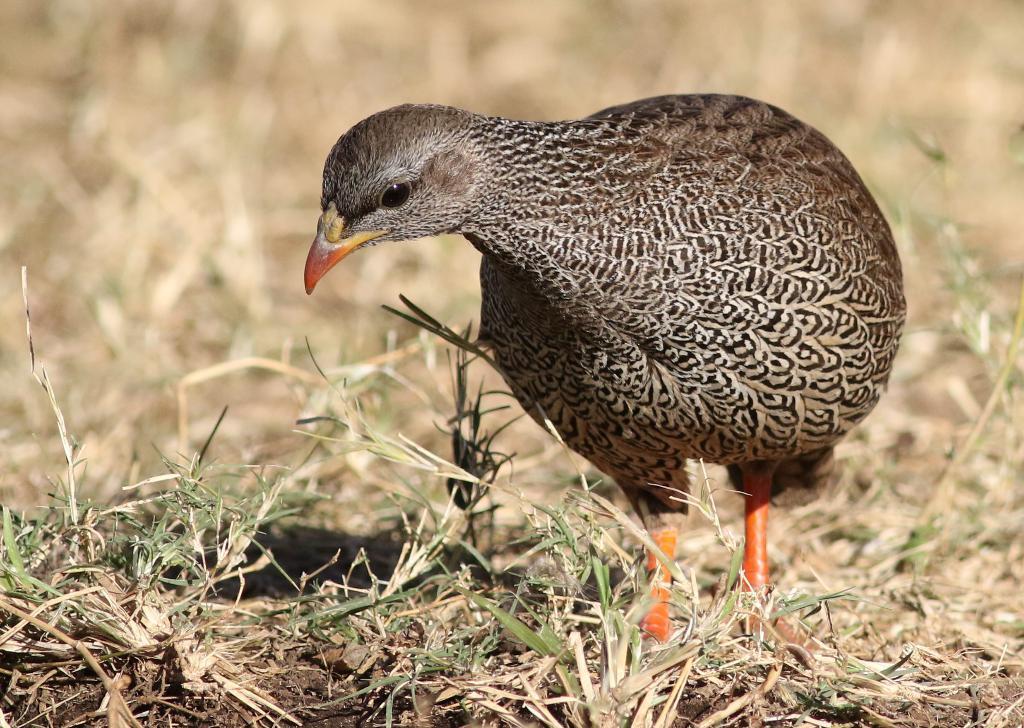Describe this image in one or two sentences. In this image I can see grass and a brown color bird. I can also see this image is little bit blurry from background. 